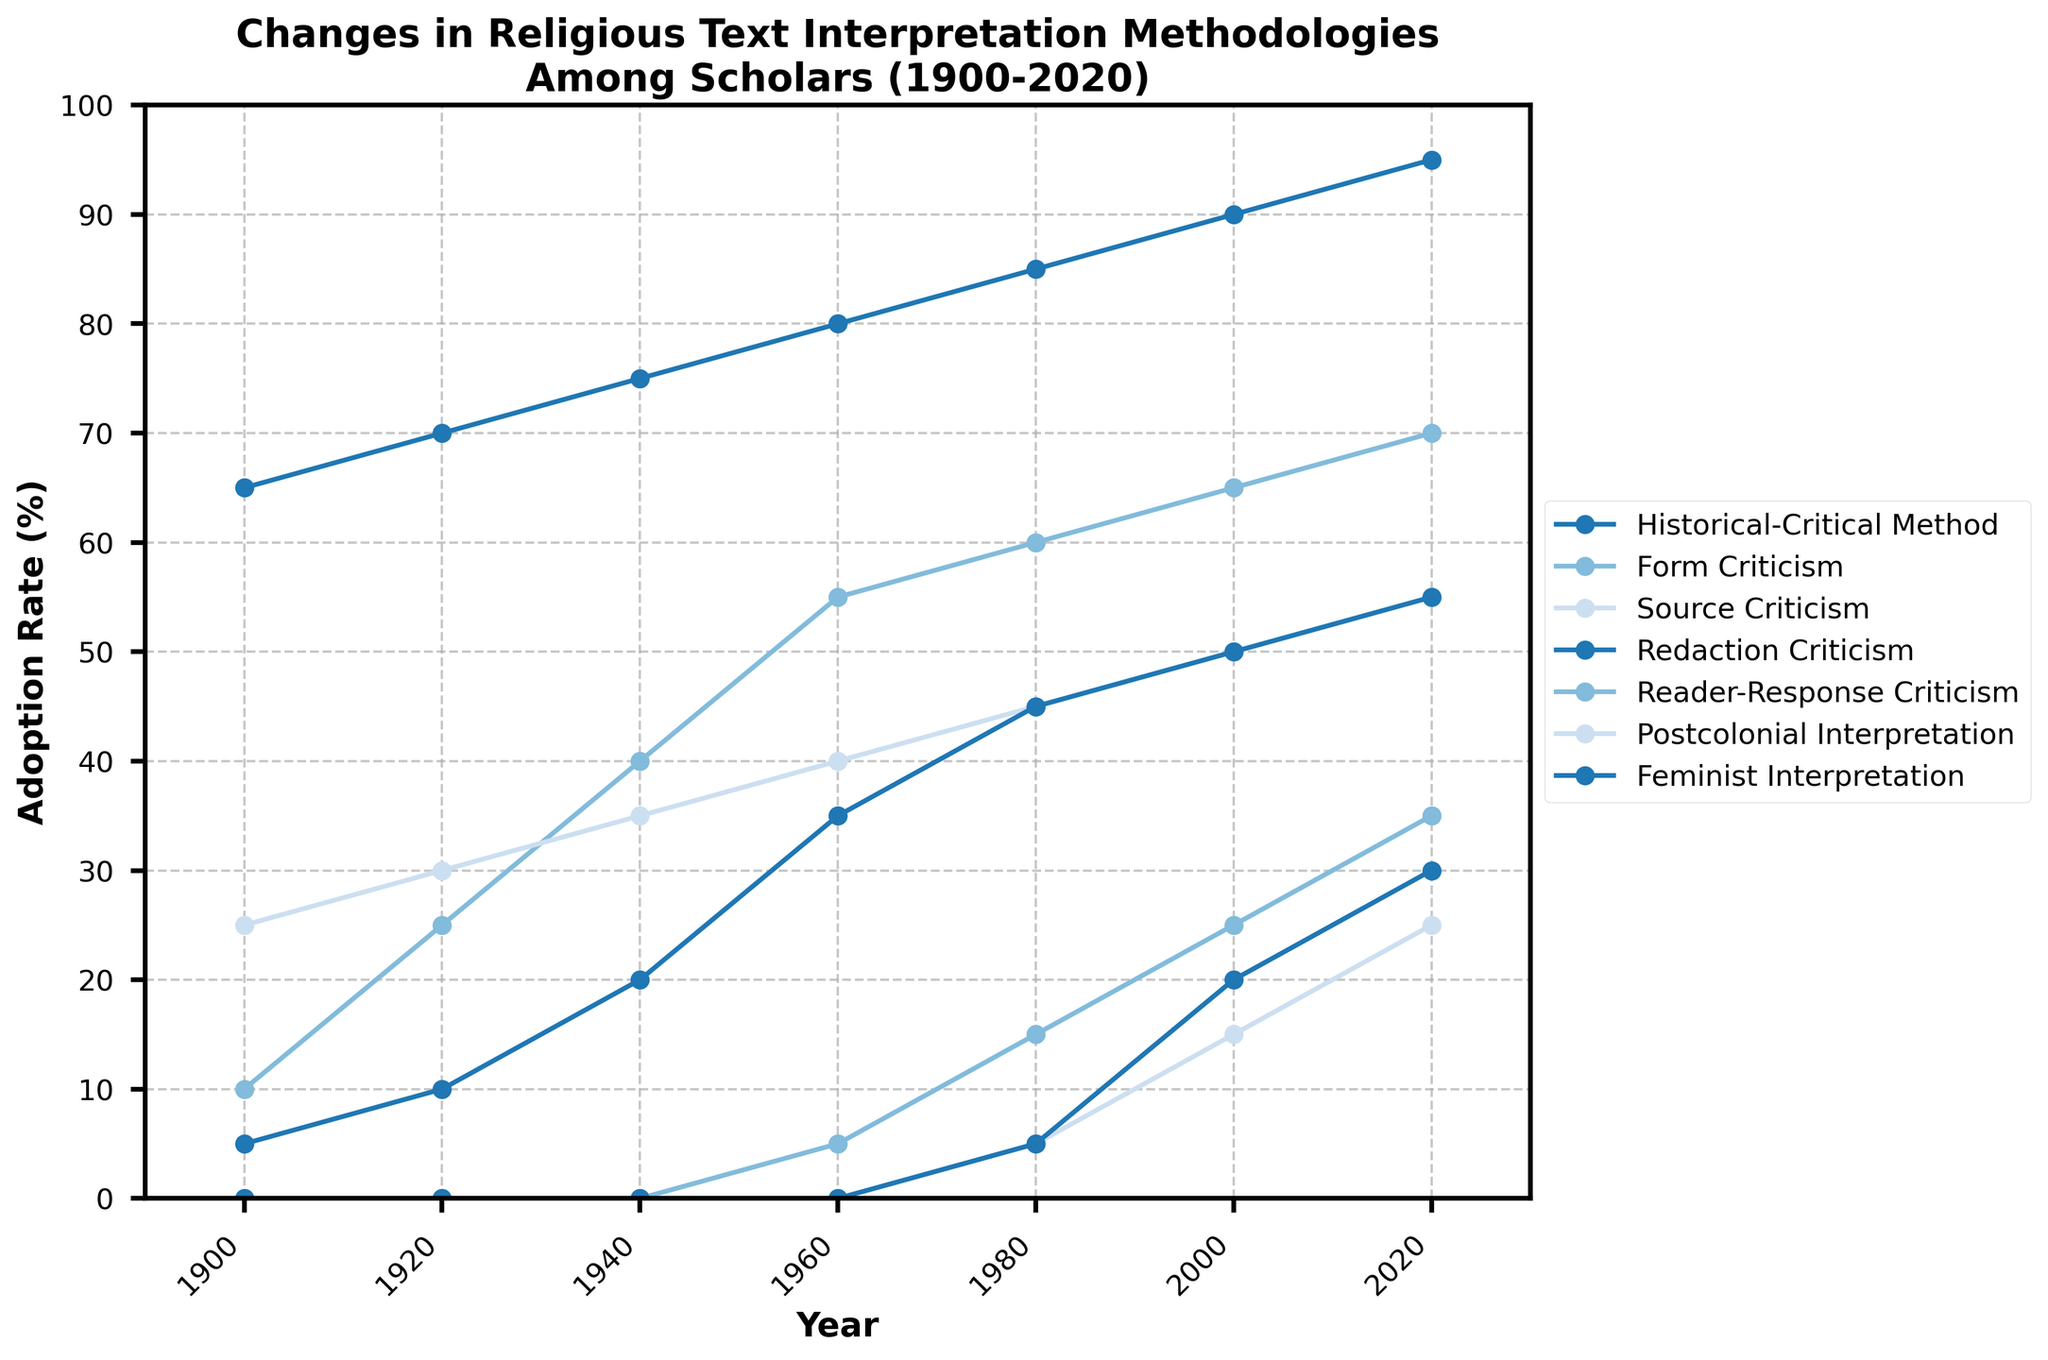Which interpretation methodology had the highest adoption rate in 1900? The plot shows the adoption rate of several methodologies over time. In 1900, the "Historical-Critical Method" had the highest adoption rate at 65%.
Answer: Historical-Critical Method Which years show a noticeable increase in the adoption rate for Feminist Interpretation? By looking at the plot, there's no adoption rate for Feminist Interpretation until 1960. From 1960 (5%) to 2020 (30%), we see noticeable increases, especially from 1980 onward.
Answer: 1980, 2000 How did the adoption rate of Postcolonial Interpretation change between 1980 and 2020? The plot shows that Postcolonial Interpretation was first adopted in 1980 with a 5% adoption rate. By 2020, it increased to 25%. This indicates it increased by 20 percentage points over the 40-year span.
Answer: Increased by 20% Which interpretation methodology saw the least change in adoption rate from 1900 to 2020? In comparing the start and end percentages of the methodologies over time, "Source Criticism" increased from 25% in 1900 to 55% in 2020, which constitutes a change of 30 percentage points. This is less compared to others like the "Historical-Critical Method" which increased by 30 percentage points from 65% to 95%.
Answer: Source Criticism Which two interpretation methodologies had the closest adoption rates in the year 1980? The adoption rates in 1980 for "Form Criticism" and "Source Criticism" were 60% and 45% respectively. The difference is 15 percentage points (60% - 45% = 15%). "Redaction Criticism" and "Form Criticism" also had a 15 percentage point difference (45% - 60% = -15%). These differences are the closest among the methodologies.
Answer: Form Criticism and Source Criticism / Form Criticism and Redaction Criticism What is the approximate average adoption rate of Redaction Criticism from 1900 to 2020? The data points for Redaction Criticism are (5, 10, 20, 35, 45, 50, 55). Adding them up: 5 + 10 + 20 + 35 + 45 + 50 + 55 = 220. There are 7 data points, so the average is 220 / 7 ≈ 31.43%.
Answer: 31.43% Which methodologies showed an initial increase by at least 15% between 1900 and 1920? The two methodologies that show this change are "Form Criticism" (from 10% in 1900 to 25% in 1920, an increase of 15%) and "Source Criticism" (from 25% in 1900 to 30% in 1920, a change of 5%). Redaction Criticism shows an increase from 5% to 10%, which is a 5% change. Therefore, only "Form Criticism" meets the condition.
Answer: Form Criticism 